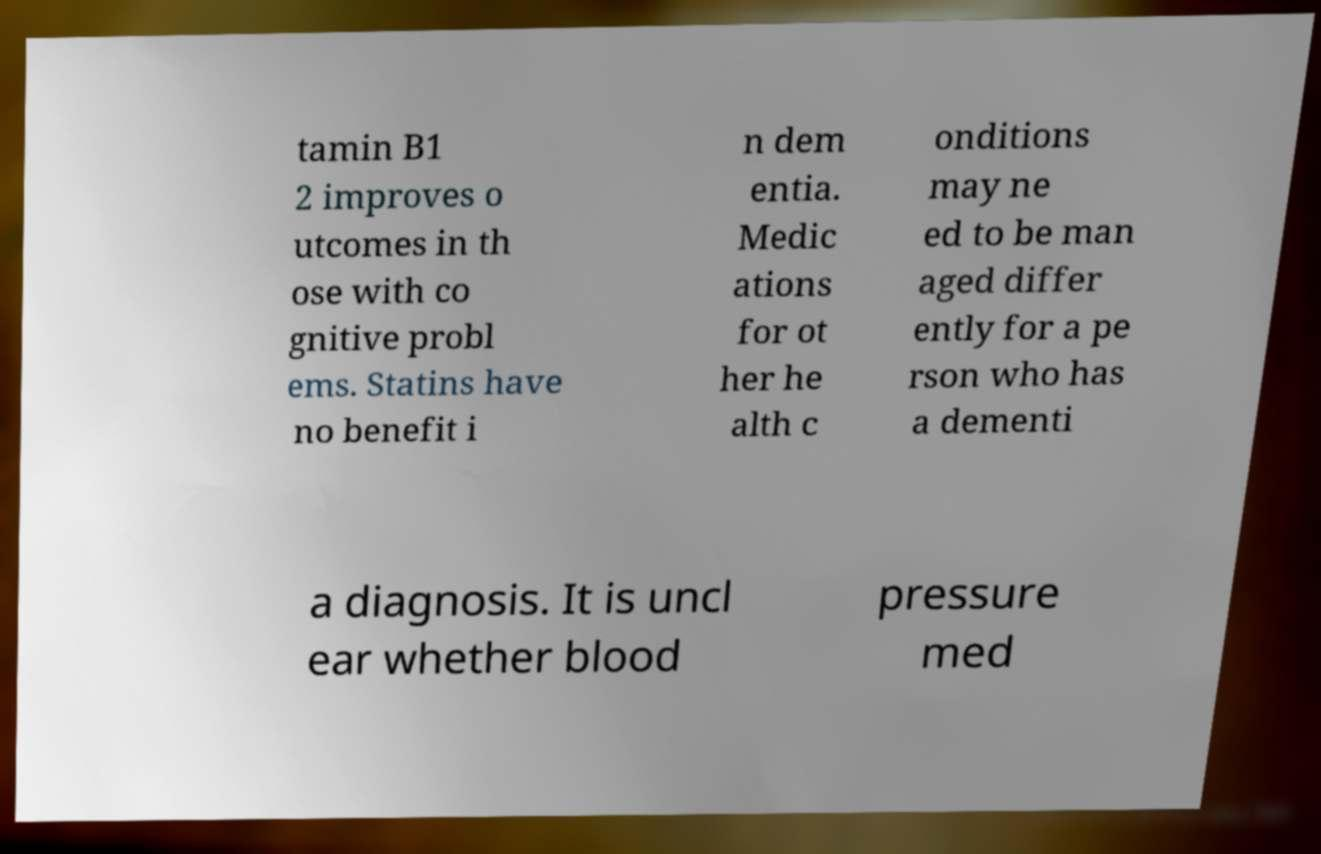I need the written content from this picture converted into text. Can you do that? tamin B1 2 improves o utcomes in th ose with co gnitive probl ems. Statins have no benefit i n dem entia. Medic ations for ot her he alth c onditions may ne ed to be man aged differ ently for a pe rson who has a dementi a diagnosis. It is uncl ear whether blood pressure med 